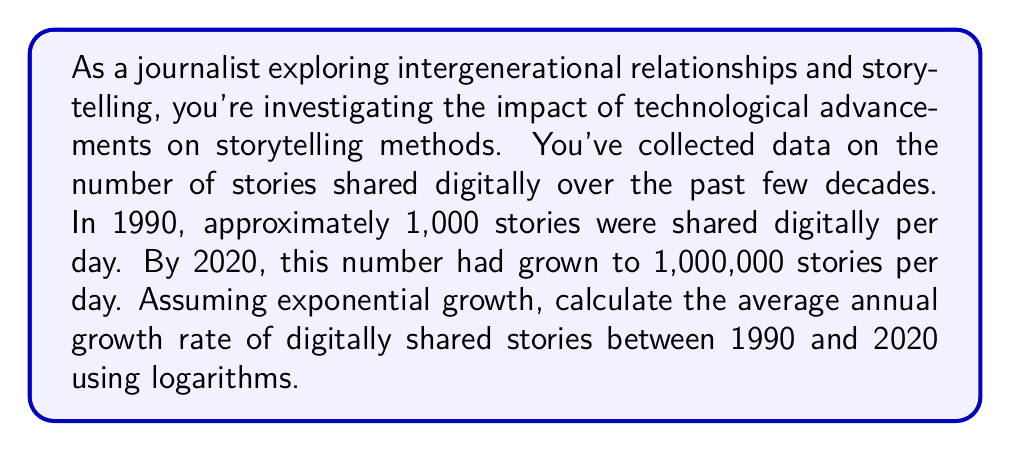Solve this math problem. To solve this problem, we'll use the exponential growth formula and logarithms:

1. The exponential growth formula is:
   $A = P(1 + r)^t$
   Where:
   $A$ = Final amount
   $P$ = Initial amount
   $r$ = Annual growth rate
   $t$ = Time in years

2. We have:
   $P = 1,000$ (stories in 1990)
   $A = 1,000,000$ (stories in 2020)
   $t = 30$ years (from 1990 to 2020)

3. Substituting these values:
   $1,000,000 = 1,000(1 + r)^{30}$

4. Divide both sides by 1,000:
   $1,000 = (1 + r)^{30}$

5. Take the natural logarithm of both sides:
   $\ln(1,000) = 30 \ln(1 + r)$

6. Simplify:
   $6.908 = 30 \ln(1 + r)$

7. Divide both sides by 30:
   $\frac{6.908}{30} = \ln(1 + r)$

8. Take $e$ to the power of both sides:
   $e^{\frac{6.908}{30}} = 1 + r$

9. Subtract 1 from both sides:
   $e^{\frac{6.908}{30}} - 1 = r$

10. Calculate:
    $r \approx 0.2589$ or 25.89%
Answer: The average annual growth rate of digitally shared stories between 1990 and 2020 was approximately 25.89%. 